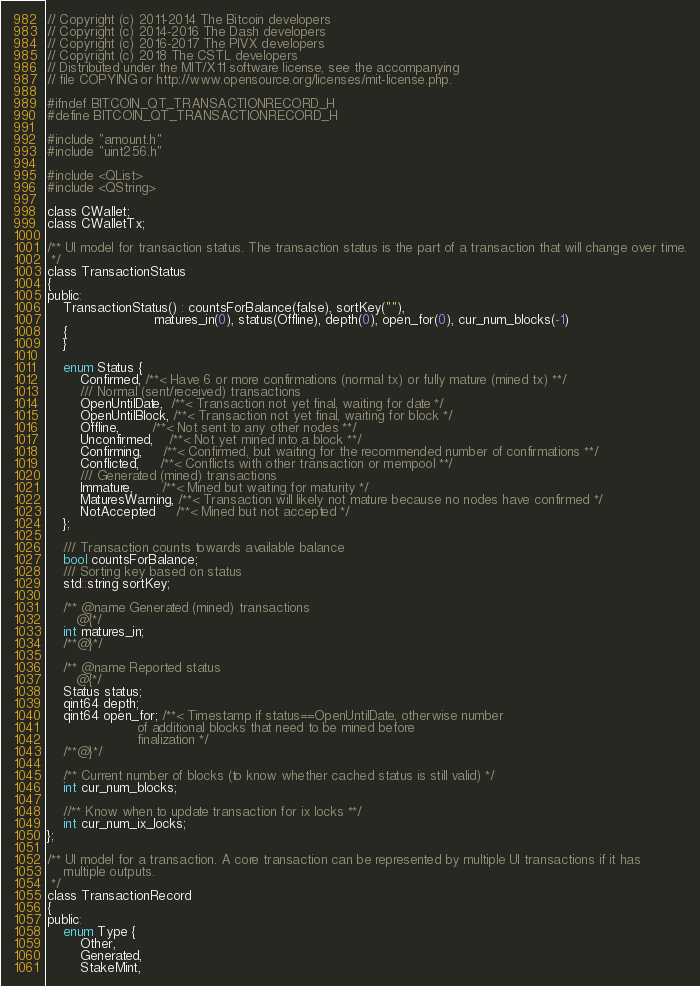<code> <loc_0><loc_0><loc_500><loc_500><_C_>// Copyright (c) 2011-2014 The Bitcoin developers
// Copyright (c) 2014-2016 The Dash developers
// Copyright (c) 2016-2017 The PIVX developers
// Copyright (c) 2018 The CSTL developers
// Distributed under the MIT/X11 software license, see the accompanying
// file COPYING or http://www.opensource.org/licenses/mit-license.php.

#ifndef BITCOIN_QT_TRANSACTIONRECORD_H
#define BITCOIN_QT_TRANSACTIONRECORD_H

#include "amount.h"
#include "uint256.h"

#include <QList>
#include <QString>

class CWallet;
class CWalletTx;

/** UI model for transaction status. The transaction status is the part of a transaction that will change over time.
 */
class TransactionStatus
{
public:
    TransactionStatus() : countsForBalance(false), sortKey(""),
                          matures_in(0), status(Offline), depth(0), open_for(0), cur_num_blocks(-1)
    {
    }

    enum Status {
        Confirmed, /**< Have 6 or more confirmations (normal tx) or fully mature (mined tx) **/
        /// Normal (sent/received) transactions
        OpenUntilDate,  /**< Transaction not yet final, waiting for date */
        OpenUntilBlock, /**< Transaction not yet final, waiting for block */
        Offline,        /**< Not sent to any other nodes **/
        Unconfirmed,    /**< Not yet mined into a block **/
        Confirming,     /**< Confirmed, but waiting for the recommended number of confirmations **/
        Conflicted,     /**< Conflicts with other transaction or mempool **/
        /// Generated (mined) transactions
        Immature,       /**< Mined but waiting for maturity */
        MaturesWarning, /**< Transaction will likely not mature because no nodes have confirmed */
        NotAccepted     /**< Mined but not accepted */
    };

    /// Transaction counts towards available balance
    bool countsForBalance;
    /// Sorting key based on status
    std::string sortKey;

    /** @name Generated (mined) transactions
       @{*/
    int matures_in;
    /**@}*/

    /** @name Reported status
       @{*/
    Status status;
    qint64 depth;
    qint64 open_for; /**< Timestamp if status==OpenUntilDate, otherwise number
                      of additional blocks that need to be mined before
                      finalization */
    /**@}*/

    /** Current number of blocks (to know whether cached status is still valid) */
    int cur_num_blocks;

    //** Know when to update transaction for ix locks **/
    int cur_num_ix_locks;
};

/** UI model for a transaction. A core transaction can be represented by multiple UI transactions if it has
    multiple outputs.
 */
class TransactionRecord
{
public:
    enum Type {
        Other,
        Generated,
        StakeMint,</code> 